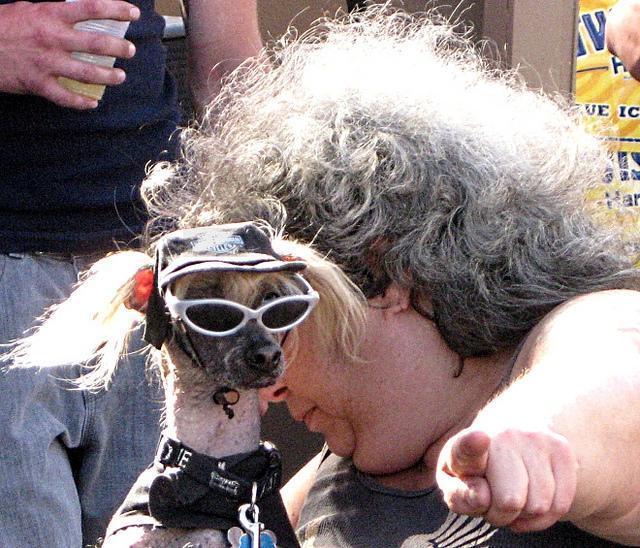How many people are in the picture?
Give a very brief answer. 2. 